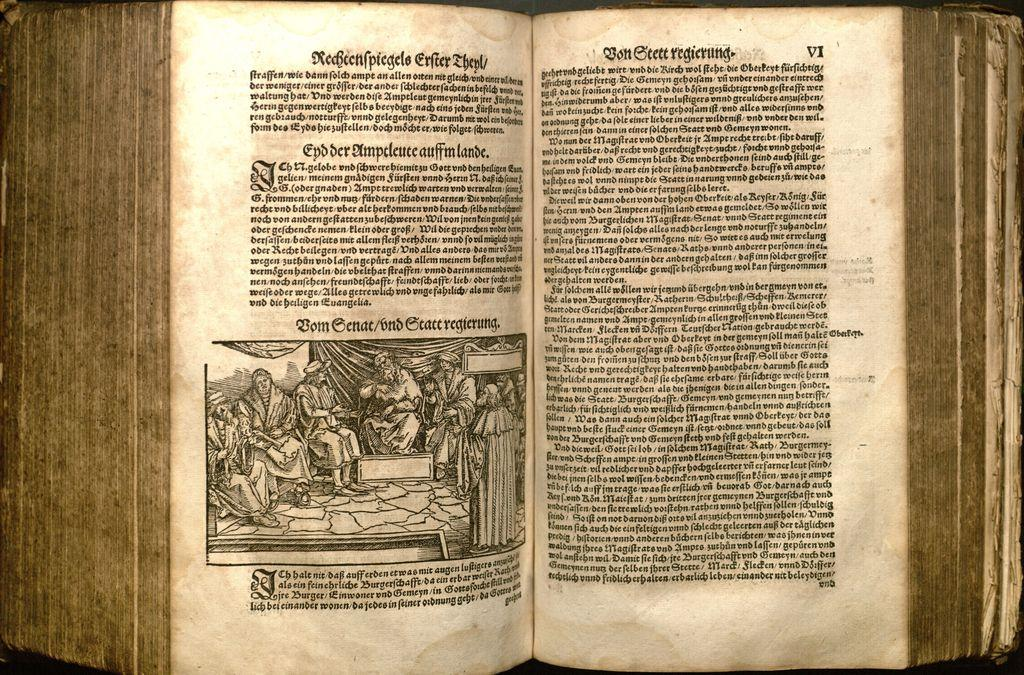Provide a one-sentence caption for the provided image. A old book opened and written in foreign language saying Redeenpiegeels. 